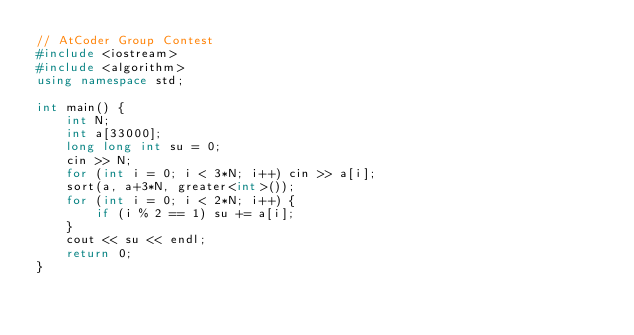<code> <loc_0><loc_0><loc_500><loc_500><_C++_>// AtCoder Group Contest
#include <iostream>
#include <algorithm>
using namespace std;

int main() {
    int N;
    int a[33000];
    long long int su = 0;
    cin >> N;
    for (int i = 0; i < 3*N; i++) cin >> a[i];
    sort(a, a+3*N, greater<int>());
    for (int i = 0; i < 2*N; i++) {
        if (i % 2 == 1) su += a[i];
    }
    cout << su << endl;
    return 0;
}</code> 